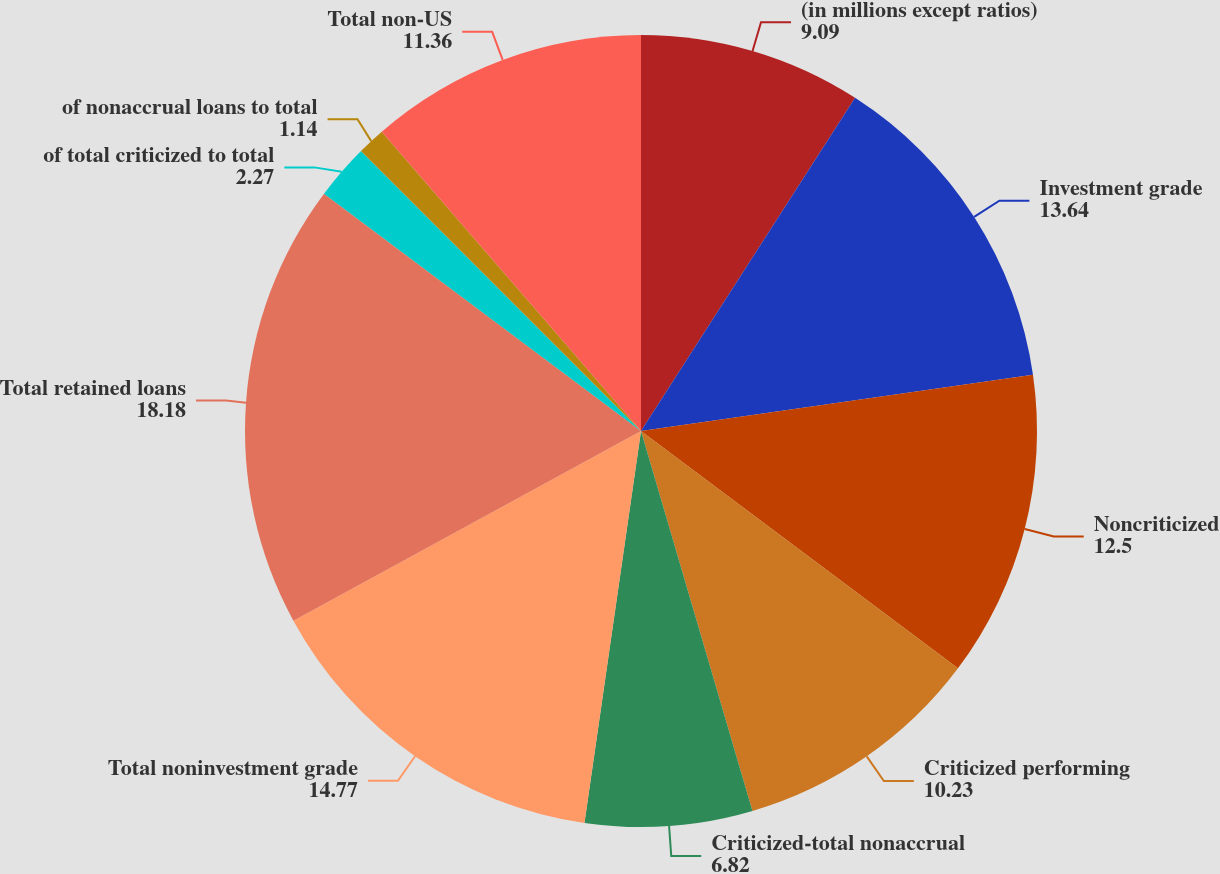<chart> <loc_0><loc_0><loc_500><loc_500><pie_chart><fcel>(in millions except ratios)<fcel>Investment grade<fcel>Noncriticized<fcel>Criticized performing<fcel>Criticized-total nonaccrual<fcel>Total noninvestment grade<fcel>Total retained loans<fcel>of total criticized to total<fcel>of nonaccrual loans to total<fcel>Total non-US<nl><fcel>9.09%<fcel>13.64%<fcel>12.5%<fcel>10.23%<fcel>6.82%<fcel>14.77%<fcel>18.18%<fcel>2.27%<fcel>1.14%<fcel>11.36%<nl></chart> 